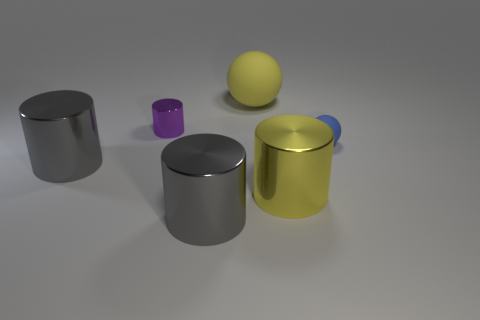Subtract all big yellow cylinders. How many cylinders are left? 3 Add 1 tiny rubber balls. How many objects exist? 7 Subtract all yellow spheres. How many spheres are left? 1 Subtract 1 balls. How many balls are left? 1 Subtract all cyan spheres. How many gray cylinders are left? 2 Subtract all cylinders. How many objects are left? 2 Subtract all yellow balls. Subtract all cyan blocks. How many balls are left? 1 Subtract all shiny cylinders. Subtract all tiny purple metal things. How many objects are left? 1 Add 3 tiny purple cylinders. How many tiny purple cylinders are left? 4 Add 5 yellow cylinders. How many yellow cylinders exist? 6 